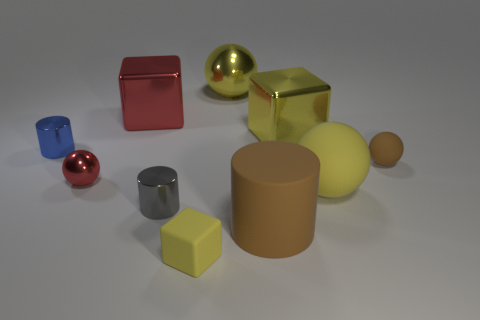How might the lighting in the scene affect our perception of the objects? The lighting plays a crucial role in our perception. It casts soft shadows behind the objects, indicating a light source from the front. Highlights on the metallic objects suggest a specular reflection, making them appear glossy. Furthermore, the way light diffuses on the matte surfaces of the cylinders allows us to distinguish between the different textures. The strength and direction of the light help in revealing the volume, depth, and material quality of each object. 